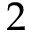<formula> <loc_0><loc_0><loc_500><loc_500>2</formula> 